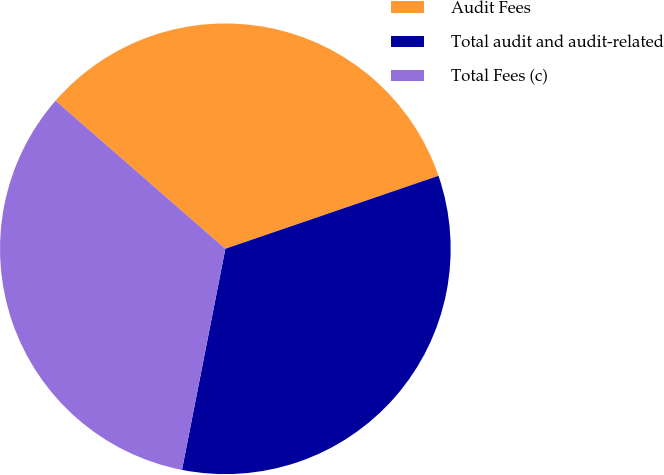Convert chart to OTSL. <chart><loc_0><loc_0><loc_500><loc_500><pie_chart><fcel>Audit Fees<fcel>Total audit and audit-related<fcel>Total Fees (c)<nl><fcel>33.33%<fcel>33.33%<fcel>33.33%<nl></chart> 